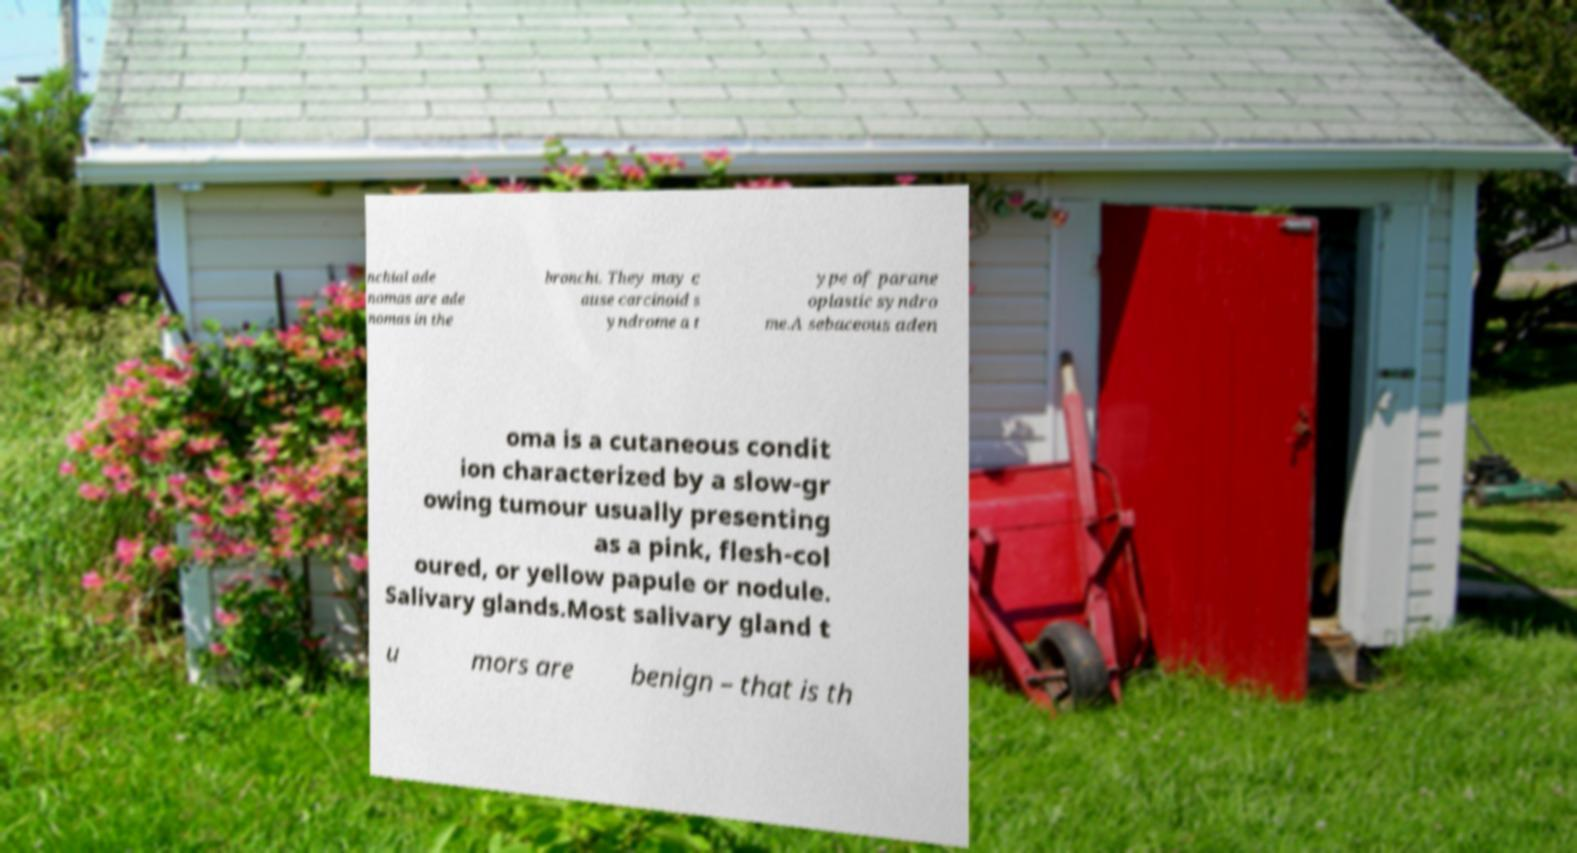Could you assist in decoding the text presented in this image and type it out clearly? nchial ade nomas are ade nomas in the bronchi. They may c ause carcinoid s yndrome a t ype of parane oplastic syndro me.A sebaceous aden oma is a cutaneous condit ion characterized by a slow-gr owing tumour usually presenting as a pink, flesh-col oured, or yellow papule or nodule. Salivary glands.Most salivary gland t u mors are benign – that is th 